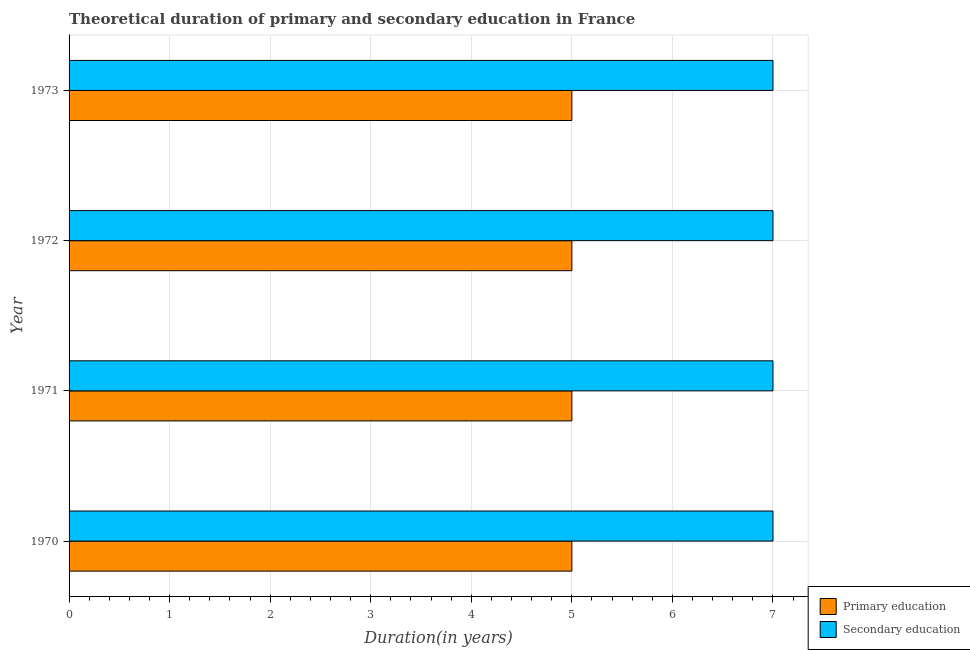How many groups of bars are there?
Keep it short and to the point. 4. Are the number of bars per tick equal to the number of legend labels?
Provide a succinct answer. Yes. How many bars are there on the 1st tick from the bottom?
Ensure brevity in your answer.  2. What is the duration of primary education in 1971?
Offer a terse response. 5. Across all years, what is the maximum duration of primary education?
Ensure brevity in your answer.  5. Across all years, what is the minimum duration of secondary education?
Give a very brief answer. 7. In which year was the duration of secondary education maximum?
Your answer should be compact. 1970. What is the total duration of secondary education in the graph?
Offer a very short reply. 28. What is the difference between the duration of secondary education in 1973 and the duration of primary education in 1970?
Provide a short and direct response. 2. In the year 1970, what is the difference between the duration of primary education and duration of secondary education?
Give a very brief answer. -2. What is the ratio of the duration of secondary education in 1970 to that in 1972?
Offer a very short reply. 1. Is the duration of primary education in 1971 less than that in 1973?
Provide a succinct answer. No. Is the sum of the duration of primary education in 1972 and 1973 greater than the maximum duration of secondary education across all years?
Offer a very short reply. Yes. What does the 2nd bar from the top in 1971 represents?
Offer a very short reply. Primary education. What does the 1st bar from the bottom in 1973 represents?
Give a very brief answer. Primary education. Are all the bars in the graph horizontal?
Provide a succinct answer. Yes. How many years are there in the graph?
Your answer should be very brief. 4. What is the title of the graph?
Your answer should be compact. Theoretical duration of primary and secondary education in France. What is the label or title of the X-axis?
Offer a very short reply. Duration(in years). What is the label or title of the Y-axis?
Provide a succinct answer. Year. What is the Duration(in years) of Primary education in 1970?
Make the answer very short. 5. What is the Duration(in years) in Secondary education in 1970?
Provide a succinct answer. 7. What is the Duration(in years) of Primary education in 1971?
Offer a terse response. 5. What is the Duration(in years) of Secondary education in 1972?
Provide a short and direct response. 7. What is the Duration(in years) of Primary education in 1973?
Offer a terse response. 5. What is the Duration(in years) of Secondary education in 1973?
Ensure brevity in your answer.  7. Across all years, what is the maximum Duration(in years) in Primary education?
Make the answer very short. 5. Across all years, what is the maximum Duration(in years) of Secondary education?
Make the answer very short. 7. Across all years, what is the minimum Duration(in years) of Secondary education?
Offer a very short reply. 7. What is the difference between the Duration(in years) of Primary education in 1970 and that in 1971?
Offer a very short reply. 0. What is the difference between the Duration(in years) in Secondary education in 1970 and that in 1971?
Provide a short and direct response. 0. What is the difference between the Duration(in years) in Secondary education in 1970 and that in 1972?
Provide a succinct answer. 0. What is the difference between the Duration(in years) of Primary education in 1970 and that in 1973?
Provide a succinct answer. 0. What is the difference between the Duration(in years) of Primary education in 1971 and that in 1972?
Give a very brief answer. 0. What is the difference between the Duration(in years) in Primary education in 1971 and that in 1973?
Provide a short and direct response. 0. What is the difference between the Duration(in years) in Secondary education in 1972 and that in 1973?
Your response must be concise. 0. What is the difference between the Duration(in years) of Primary education in 1970 and the Duration(in years) of Secondary education in 1972?
Offer a terse response. -2. What is the difference between the Duration(in years) of Primary education in 1970 and the Duration(in years) of Secondary education in 1973?
Your answer should be very brief. -2. What is the difference between the Duration(in years) of Primary education in 1972 and the Duration(in years) of Secondary education in 1973?
Your response must be concise. -2. In the year 1970, what is the difference between the Duration(in years) in Primary education and Duration(in years) in Secondary education?
Ensure brevity in your answer.  -2. In the year 1971, what is the difference between the Duration(in years) in Primary education and Duration(in years) in Secondary education?
Your answer should be very brief. -2. In the year 1973, what is the difference between the Duration(in years) in Primary education and Duration(in years) in Secondary education?
Give a very brief answer. -2. What is the ratio of the Duration(in years) of Secondary education in 1970 to that in 1971?
Offer a very short reply. 1. What is the ratio of the Duration(in years) of Primary education in 1970 to that in 1972?
Ensure brevity in your answer.  1. What is the ratio of the Duration(in years) of Secondary education in 1970 to that in 1972?
Your answer should be compact. 1. What is the ratio of the Duration(in years) in Secondary education in 1970 to that in 1973?
Make the answer very short. 1. What is the ratio of the Duration(in years) in Primary education in 1971 to that in 1972?
Make the answer very short. 1. What is the ratio of the Duration(in years) of Secondary education in 1971 to that in 1972?
Your answer should be very brief. 1. What is the ratio of the Duration(in years) in Primary education in 1971 to that in 1973?
Offer a terse response. 1. What is the ratio of the Duration(in years) in Secondary education in 1971 to that in 1973?
Give a very brief answer. 1. What is the ratio of the Duration(in years) in Primary education in 1972 to that in 1973?
Provide a short and direct response. 1. What is the difference between the highest and the second highest Duration(in years) in Secondary education?
Your answer should be very brief. 0. What is the difference between the highest and the lowest Duration(in years) of Primary education?
Your response must be concise. 0. What is the difference between the highest and the lowest Duration(in years) of Secondary education?
Keep it short and to the point. 0. 